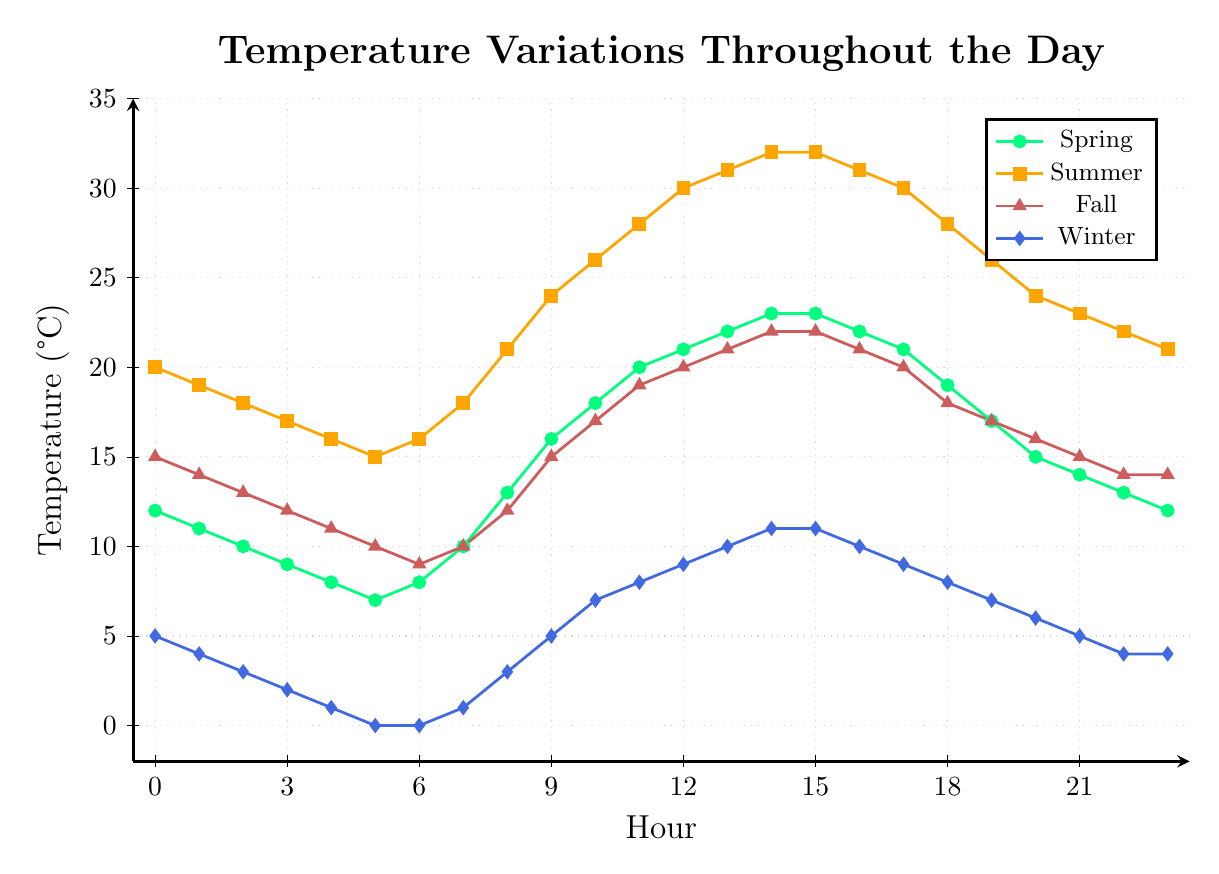What time does the temperature peak in Summer? To find the peak temperature time in Summer, locate the time where the Summer line (orange with square markers) reaches its highest point. This occurs between hours 14:00 and 15:00.
Answer: 14:00 Which season experiences the lowest temperature, and at what time? Look for the lowest point across all the lines. The Winter line (blue with diamond markers) reaches the lowest point, specifically at hour 5:00 AM where the temperature is 0 degrees.
Answer: Winter at 5:00 AM What is the difference between the peak temperatures of Summer and Winter? The peak temperature in Summer is 32 degrees (at 14:00-15:00), and in Winter, it is 11 degrees (at 14:00-15:00). Subtract the Winter peak from the Summer peak: 32 - 11 = 21 degrees.
Answer: 21 degrees At what time do Spring and Fall have the same temperature, and what is that temperature? Locate the points where the Spring (green with circle markers) and Fall (brown with triangle markers) lines intersect. They intersect at hour 15:00, both having a temperature of 22 degrees.
Answer: 15:00, 22 degrees Which season has the steepest temperature rise in the morning, and during which hours does this occur? Look for the line with the steepest upward slope in the morning (hours 6:00 to 12:00). The steepest increase is in Summer, from 16 degrees at 6:00 AM to 30 degrees at 12:00 PM, a difference of 14 degrees.
Answer: Summer, 6:00-12:00 How does the temperature at 10:00 differ between Spring and Fall? Find the temperature values at 10:00 for both Spring (green line, 18 degrees) and Fall (brown line, 17 degrees) and calculate their difference: 18 - 17 = 1 degree.
Answer: 1 degree What is the average temperature in Winter from midnight to 6:00 AM? Add the Winter temperatures from hour 0 to hour 6 and divide by the number of hours: (5 + 4 + 3 + 2 + 1 + 0 + 0)/7 = 2.14 (rounded to two decimal places).
Answer: 2.14 degrees Which season shows the least variation in temperature throughout the day? Compare the temperature range (maximum - minimum) for each season:
- Spring: Max 23, Min 7, Range 16
- Summer: Max 32, Min 15, Range 17
- Fall: Max 22, Min 9, Range 13
- Winter: Max 11, Min 0, Range 11
Winter has the smallest range (11 degrees), so it shows the least variation.
Answer: Winter During which hours does Summer have a temperature of exactly 26 degrees? Identify the points on the Summer line that correspond to a temperature of 26 degrees: they occur at 10:00 and 19:00.
Answer: 10:00, 19:00 What is the temperature difference between Summer and Winter at 18:00? Find the temperatures at 18:00 for Summer (orange line, 28 degrees) and Winter (blue line, 8 degrees), and calculate their difference: 28 - 8 = 20 degrees.
Answer: 20 degrees 